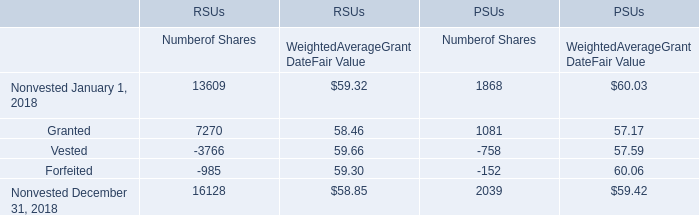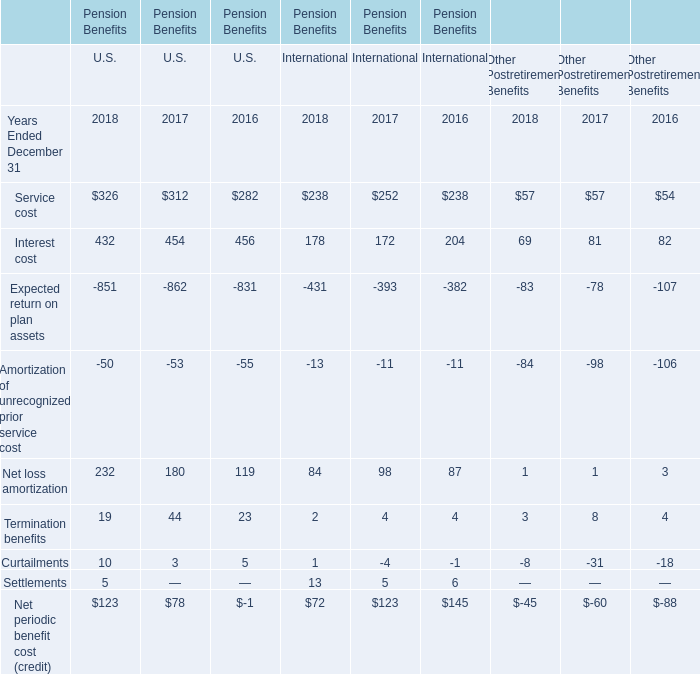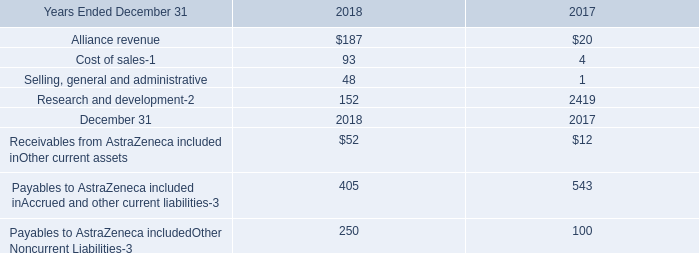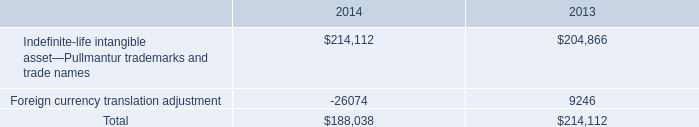from 2013-2014 , what percentage of total intangible assets were recorded in 2014? 
Computations: (100 * (188038 / (188038 + 214112)))
Answer: 46.75817. 